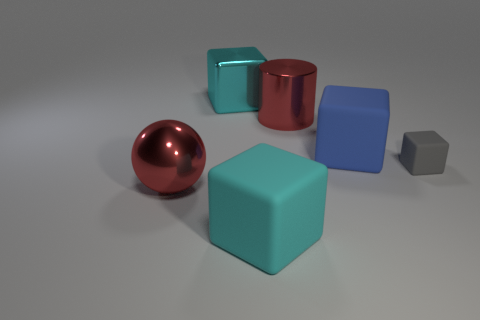Are there more tiny rubber blocks left of the small matte object than large blue cubes that are behind the big red cylinder?
Offer a very short reply. No. The large red thing that is on the right side of the cyan object that is in front of the large red metal object behind the small gray rubber block is what shape?
Provide a short and direct response. Cylinder. The gray matte thing on the right side of the large red shiny object that is in front of the gray thing is what shape?
Your response must be concise. Cube. Is there a small gray object made of the same material as the large cylinder?
Ensure brevity in your answer.  No. There is a rubber cube that is the same color as the shiny cube; what size is it?
Give a very brief answer. Large. How many green objects are either large matte cylinders or spheres?
Your response must be concise. 0. Are there any tiny matte cylinders that have the same color as the metallic cylinder?
Offer a terse response. No. What size is the red object that is made of the same material as the ball?
Provide a succinct answer. Large. What number of blocks are big matte things or blue things?
Your response must be concise. 2. Is the number of big cyan objects greater than the number of large yellow blocks?
Give a very brief answer. Yes. 